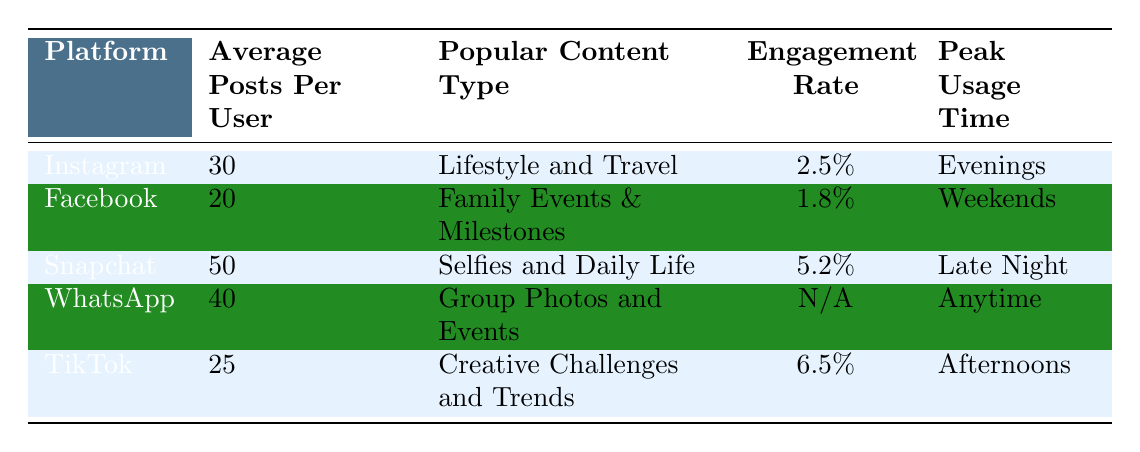What is the peak usage time for Instagram? The peak usage time for Instagram is listed under the "Peak Usage Time" column for that platform, which is "Evenings."
Answer: Evenings Which platform has the highest average posts per user? By comparing the "Average Posts Per User" values across all platforms, Snapchat has the highest value of 50 posts per user.
Answer: Snapchat Are engagement rates available for WhatsApp? The engagement rate for WhatsApp is indicated in the table as "N/A," meaning that no data is available for this metric.
Answer: No What is the average number of posts per user across all platforms? The average can be calculated by summing the average posts from all platforms: (30 + 20 + 50 + 40 + 25) = 165, and dividing by the number of platforms (5). So, 165 / 5 = 33.
Answer: 33 Does Snapchat have a lower engagement rate than Instagram? Comparing the engagement rates in the table, Snapchat has an engagement rate of 5.2%, which is higher than Instagram's rate of 2.5%. Therefore, the statement is false.
Answer: No What are the popular content types for TikTok? The popular content type for TikTok is specified in the "Popular Content Type" column, which is "Creative Challenges and Trends."
Answer: Creative Challenges and Trends Which platforms have a peak usage time on the weekends? From the table, only Facebook has a peak usage time listed as "Weekends."
Answer: Facebook What is the total engagement rate for Instagram and TikTok combined? Since engagement rates are given as percentages, we first find the total engagement rate by adding the two rates: 2.5% (Instagram) + 6.5% (TikTok) = 9%. The combined engagement rate is thus simply the sum of the two percentages.
Answer: 9% 